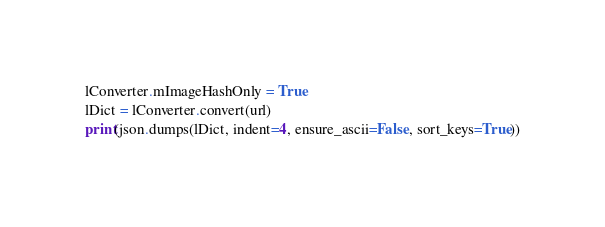Convert code to text. <code><loc_0><loc_0><loc_500><loc_500><_Python_>lConverter.mImageHashOnly = True
lDict = lConverter.convert(url)
print(json.dumps(lDict, indent=4, ensure_ascii=False, sort_keys=True))
</code> 